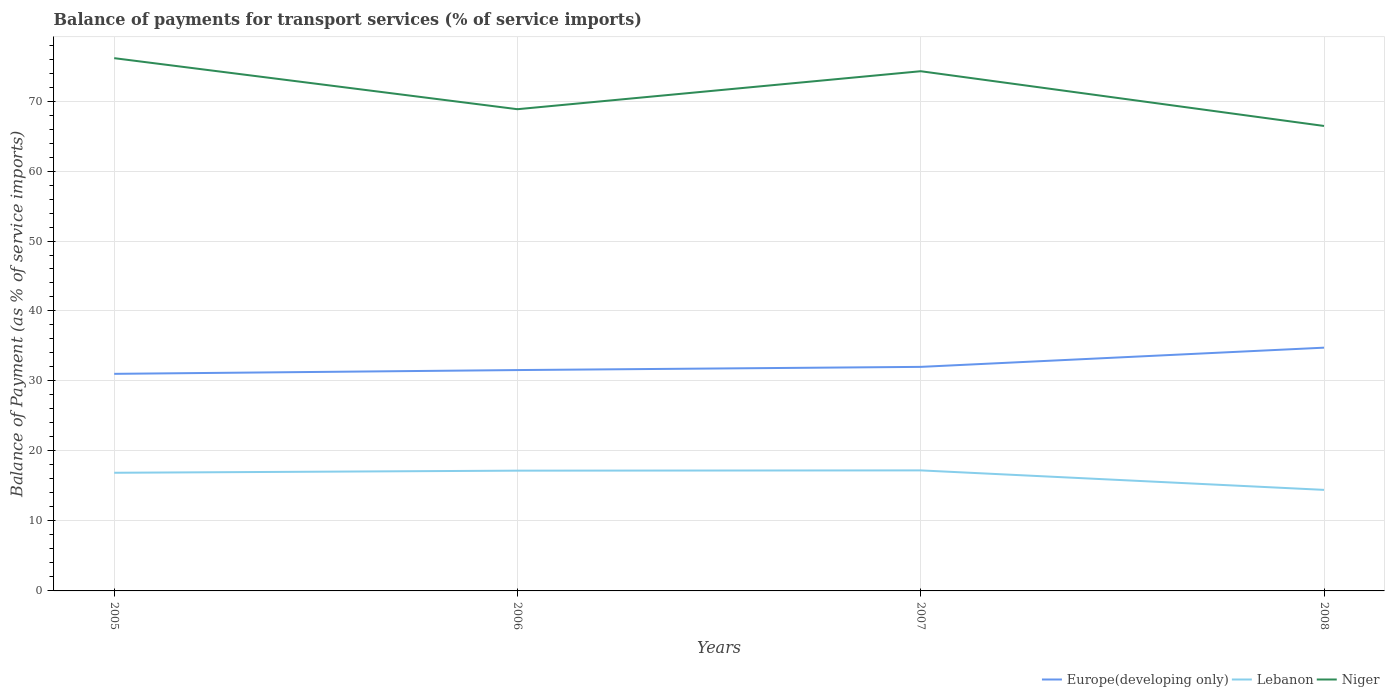How many different coloured lines are there?
Make the answer very short. 3. Does the line corresponding to Niger intersect with the line corresponding to Lebanon?
Provide a short and direct response. No. Across all years, what is the maximum balance of payments for transport services in Lebanon?
Provide a short and direct response. 14.44. In which year was the balance of payments for transport services in Lebanon maximum?
Offer a very short reply. 2008. What is the total balance of payments for transport services in Europe(developing only) in the graph?
Offer a very short reply. -3.2. What is the difference between the highest and the second highest balance of payments for transport services in Europe(developing only)?
Your response must be concise. 3.74. What is the difference between the highest and the lowest balance of payments for transport services in Lebanon?
Offer a very short reply. 3. Is the balance of payments for transport services in Lebanon strictly greater than the balance of payments for transport services in Niger over the years?
Offer a very short reply. Yes. How many years are there in the graph?
Offer a very short reply. 4. Does the graph contain any zero values?
Offer a terse response. No. Does the graph contain grids?
Make the answer very short. Yes. How are the legend labels stacked?
Offer a terse response. Horizontal. What is the title of the graph?
Your answer should be very brief. Balance of payments for transport services (% of service imports). Does "Central African Republic" appear as one of the legend labels in the graph?
Ensure brevity in your answer.  No. What is the label or title of the Y-axis?
Your response must be concise. Balance of Payment (as % of service imports). What is the Balance of Payment (as % of service imports) of Europe(developing only) in 2005?
Keep it short and to the point. 31.02. What is the Balance of Payment (as % of service imports) of Lebanon in 2005?
Provide a short and direct response. 16.88. What is the Balance of Payment (as % of service imports) in Niger in 2005?
Give a very brief answer. 76.13. What is the Balance of Payment (as % of service imports) in Europe(developing only) in 2006?
Your answer should be very brief. 31.56. What is the Balance of Payment (as % of service imports) in Lebanon in 2006?
Give a very brief answer. 17.19. What is the Balance of Payment (as % of service imports) in Niger in 2006?
Your answer should be very brief. 68.83. What is the Balance of Payment (as % of service imports) in Europe(developing only) in 2007?
Give a very brief answer. 32.01. What is the Balance of Payment (as % of service imports) of Lebanon in 2007?
Ensure brevity in your answer.  17.22. What is the Balance of Payment (as % of service imports) in Niger in 2007?
Ensure brevity in your answer.  74.26. What is the Balance of Payment (as % of service imports) in Europe(developing only) in 2008?
Keep it short and to the point. 34.76. What is the Balance of Payment (as % of service imports) in Lebanon in 2008?
Offer a very short reply. 14.44. What is the Balance of Payment (as % of service imports) in Niger in 2008?
Keep it short and to the point. 66.44. Across all years, what is the maximum Balance of Payment (as % of service imports) of Europe(developing only)?
Make the answer very short. 34.76. Across all years, what is the maximum Balance of Payment (as % of service imports) in Lebanon?
Provide a short and direct response. 17.22. Across all years, what is the maximum Balance of Payment (as % of service imports) in Niger?
Offer a terse response. 76.13. Across all years, what is the minimum Balance of Payment (as % of service imports) of Europe(developing only)?
Your answer should be very brief. 31.02. Across all years, what is the minimum Balance of Payment (as % of service imports) of Lebanon?
Provide a succinct answer. 14.44. Across all years, what is the minimum Balance of Payment (as % of service imports) of Niger?
Your answer should be compact. 66.44. What is the total Balance of Payment (as % of service imports) in Europe(developing only) in the graph?
Offer a terse response. 129.35. What is the total Balance of Payment (as % of service imports) of Lebanon in the graph?
Your answer should be very brief. 65.73. What is the total Balance of Payment (as % of service imports) in Niger in the graph?
Ensure brevity in your answer.  285.66. What is the difference between the Balance of Payment (as % of service imports) of Europe(developing only) in 2005 and that in 2006?
Give a very brief answer. -0.54. What is the difference between the Balance of Payment (as % of service imports) in Lebanon in 2005 and that in 2006?
Ensure brevity in your answer.  -0.3. What is the difference between the Balance of Payment (as % of service imports) of Niger in 2005 and that in 2006?
Your response must be concise. 7.29. What is the difference between the Balance of Payment (as % of service imports) in Europe(developing only) in 2005 and that in 2007?
Keep it short and to the point. -1. What is the difference between the Balance of Payment (as % of service imports) in Lebanon in 2005 and that in 2007?
Offer a very short reply. -0.34. What is the difference between the Balance of Payment (as % of service imports) of Niger in 2005 and that in 2007?
Make the answer very short. 1.87. What is the difference between the Balance of Payment (as % of service imports) in Europe(developing only) in 2005 and that in 2008?
Keep it short and to the point. -3.74. What is the difference between the Balance of Payment (as % of service imports) of Lebanon in 2005 and that in 2008?
Provide a short and direct response. 2.44. What is the difference between the Balance of Payment (as % of service imports) of Niger in 2005 and that in 2008?
Make the answer very short. 9.69. What is the difference between the Balance of Payment (as % of service imports) in Europe(developing only) in 2006 and that in 2007?
Ensure brevity in your answer.  -0.45. What is the difference between the Balance of Payment (as % of service imports) of Lebanon in 2006 and that in 2007?
Your answer should be very brief. -0.04. What is the difference between the Balance of Payment (as % of service imports) of Niger in 2006 and that in 2007?
Your answer should be compact. -5.43. What is the difference between the Balance of Payment (as % of service imports) of Europe(developing only) in 2006 and that in 2008?
Offer a very short reply. -3.2. What is the difference between the Balance of Payment (as % of service imports) in Lebanon in 2006 and that in 2008?
Your answer should be very brief. 2.75. What is the difference between the Balance of Payment (as % of service imports) of Niger in 2006 and that in 2008?
Give a very brief answer. 2.39. What is the difference between the Balance of Payment (as % of service imports) in Europe(developing only) in 2007 and that in 2008?
Give a very brief answer. -2.75. What is the difference between the Balance of Payment (as % of service imports) of Lebanon in 2007 and that in 2008?
Make the answer very short. 2.78. What is the difference between the Balance of Payment (as % of service imports) of Niger in 2007 and that in 2008?
Your answer should be very brief. 7.82. What is the difference between the Balance of Payment (as % of service imports) of Europe(developing only) in 2005 and the Balance of Payment (as % of service imports) of Lebanon in 2006?
Keep it short and to the point. 13.83. What is the difference between the Balance of Payment (as % of service imports) in Europe(developing only) in 2005 and the Balance of Payment (as % of service imports) in Niger in 2006?
Keep it short and to the point. -37.81. What is the difference between the Balance of Payment (as % of service imports) in Lebanon in 2005 and the Balance of Payment (as % of service imports) in Niger in 2006?
Provide a short and direct response. -51.95. What is the difference between the Balance of Payment (as % of service imports) in Europe(developing only) in 2005 and the Balance of Payment (as % of service imports) in Lebanon in 2007?
Give a very brief answer. 13.8. What is the difference between the Balance of Payment (as % of service imports) of Europe(developing only) in 2005 and the Balance of Payment (as % of service imports) of Niger in 2007?
Ensure brevity in your answer.  -43.24. What is the difference between the Balance of Payment (as % of service imports) of Lebanon in 2005 and the Balance of Payment (as % of service imports) of Niger in 2007?
Give a very brief answer. -57.38. What is the difference between the Balance of Payment (as % of service imports) of Europe(developing only) in 2005 and the Balance of Payment (as % of service imports) of Lebanon in 2008?
Your answer should be compact. 16.58. What is the difference between the Balance of Payment (as % of service imports) in Europe(developing only) in 2005 and the Balance of Payment (as % of service imports) in Niger in 2008?
Your answer should be very brief. -35.42. What is the difference between the Balance of Payment (as % of service imports) in Lebanon in 2005 and the Balance of Payment (as % of service imports) in Niger in 2008?
Offer a terse response. -49.56. What is the difference between the Balance of Payment (as % of service imports) in Europe(developing only) in 2006 and the Balance of Payment (as % of service imports) in Lebanon in 2007?
Give a very brief answer. 14.34. What is the difference between the Balance of Payment (as % of service imports) of Europe(developing only) in 2006 and the Balance of Payment (as % of service imports) of Niger in 2007?
Offer a terse response. -42.7. What is the difference between the Balance of Payment (as % of service imports) in Lebanon in 2006 and the Balance of Payment (as % of service imports) in Niger in 2007?
Your answer should be very brief. -57.08. What is the difference between the Balance of Payment (as % of service imports) of Europe(developing only) in 2006 and the Balance of Payment (as % of service imports) of Lebanon in 2008?
Offer a terse response. 17.12. What is the difference between the Balance of Payment (as % of service imports) in Europe(developing only) in 2006 and the Balance of Payment (as % of service imports) in Niger in 2008?
Your answer should be compact. -34.88. What is the difference between the Balance of Payment (as % of service imports) in Lebanon in 2006 and the Balance of Payment (as % of service imports) in Niger in 2008?
Ensure brevity in your answer.  -49.25. What is the difference between the Balance of Payment (as % of service imports) in Europe(developing only) in 2007 and the Balance of Payment (as % of service imports) in Lebanon in 2008?
Your answer should be very brief. 17.57. What is the difference between the Balance of Payment (as % of service imports) in Europe(developing only) in 2007 and the Balance of Payment (as % of service imports) in Niger in 2008?
Provide a short and direct response. -34.43. What is the difference between the Balance of Payment (as % of service imports) in Lebanon in 2007 and the Balance of Payment (as % of service imports) in Niger in 2008?
Keep it short and to the point. -49.22. What is the average Balance of Payment (as % of service imports) in Europe(developing only) per year?
Give a very brief answer. 32.34. What is the average Balance of Payment (as % of service imports) in Lebanon per year?
Provide a succinct answer. 16.43. What is the average Balance of Payment (as % of service imports) of Niger per year?
Your response must be concise. 71.42. In the year 2005, what is the difference between the Balance of Payment (as % of service imports) of Europe(developing only) and Balance of Payment (as % of service imports) of Lebanon?
Your response must be concise. 14.13. In the year 2005, what is the difference between the Balance of Payment (as % of service imports) in Europe(developing only) and Balance of Payment (as % of service imports) in Niger?
Your answer should be compact. -45.11. In the year 2005, what is the difference between the Balance of Payment (as % of service imports) of Lebanon and Balance of Payment (as % of service imports) of Niger?
Ensure brevity in your answer.  -59.24. In the year 2006, what is the difference between the Balance of Payment (as % of service imports) in Europe(developing only) and Balance of Payment (as % of service imports) in Lebanon?
Make the answer very short. 14.37. In the year 2006, what is the difference between the Balance of Payment (as % of service imports) in Europe(developing only) and Balance of Payment (as % of service imports) in Niger?
Provide a succinct answer. -37.27. In the year 2006, what is the difference between the Balance of Payment (as % of service imports) in Lebanon and Balance of Payment (as % of service imports) in Niger?
Make the answer very short. -51.65. In the year 2007, what is the difference between the Balance of Payment (as % of service imports) in Europe(developing only) and Balance of Payment (as % of service imports) in Lebanon?
Make the answer very short. 14.79. In the year 2007, what is the difference between the Balance of Payment (as % of service imports) in Europe(developing only) and Balance of Payment (as % of service imports) in Niger?
Provide a succinct answer. -42.25. In the year 2007, what is the difference between the Balance of Payment (as % of service imports) of Lebanon and Balance of Payment (as % of service imports) of Niger?
Make the answer very short. -57.04. In the year 2008, what is the difference between the Balance of Payment (as % of service imports) of Europe(developing only) and Balance of Payment (as % of service imports) of Lebanon?
Provide a succinct answer. 20.32. In the year 2008, what is the difference between the Balance of Payment (as % of service imports) of Europe(developing only) and Balance of Payment (as % of service imports) of Niger?
Provide a short and direct response. -31.68. In the year 2008, what is the difference between the Balance of Payment (as % of service imports) of Lebanon and Balance of Payment (as % of service imports) of Niger?
Make the answer very short. -52. What is the ratio of the Balance of Payment (as % of service imports) of Europe(developing only) in 2005 to that in 2006?
Offer a terse response. 0.98. What is the ratio of the Balance of Payment (as % of service imports) in Lebanon in 2005 to that in 2006?
Provide a succinct answer. 0.98. What is the ratio of the Balance of Payment (as % of service imports) of Niger in 2005 to that in 2006?
Provide a succinct answer. 1.11. What is the ratio of the Balance of Payment (as % of service imports) of Europe(developing only) in 2005 to that in 2007?
Give a very brief answer. 0.97. What is the ratio of the Balance of Payment (as % of service imports) of Lebanon in 2005 to that in 2007?
Keep it short and to the point. 0.98. What is the ratio of the Balance of Payment (as % of service imports) in Niger in 2005 to that in 2007?
Ensure brevity in your answer.  1.03. What is the ratio of the Balance of Payment (as % of service imports) of Europe(developing only) in 2005 to that in 2008?
Provide a short and direct response. 0.89. What is the ratio of the Balance of Payment (as % of service imports) of Lebanon in 2005 to that in 2008?
Offer a very short reply. 1.17. What is the ratio of the Balance of Payment (as % of service imports) of Niger in 2005 to that in 2008?
Offer a very short reply. 1.15. What is the ratio of the Balance of Payment (as % of service imports) of Europe(developing only) in 2006 to that in 2007?
Make the answer very short. 0.99. What is the ratio of the Balance of Payment (as % of service imports) in Niger in 2006 to that in 2007?
Offer a terse response. 0.93. What is the ratio of the Balance of Payment (as % of service imports) of Europe(developing only) in 2006 to that in 2008?
Your response must be concise. 0.91. What is the ratio of the Balance of Payment (as % of service imports) of Lebanon in 2006 to that in 2008?
Your response must be concise. 1.19. What is the ratio of the Balance of Payment (as % of service imports) in Niger in 2006 to that in 2008?
Provide a succinct answer. 1.04. What is the ratio of the Balance of Payment (as % of service imports) in Europe(developing only) in 2007 to that in 2008?
Keep it short and to the point. 0.92. What is the ratio of the Balance of Payment (as % of service imports) of Lebanon in 2007 to that in 2008?
Your answer should be compact. 1.19. What is the ratio of the Balance of Payment (as % of service imports) of Niger in 2007 to that in 2008?
Offer a very short reply. 1.12. What is the difference between the highest and the second highest Balance of Payment (as % of service imports) in Europe(developing only)?
Keep it short and to the point. 2.75. What is the difference between the highest and the second highest Balance of Payment (as % of service imports) in Lebanon?
Make the answer very short. 0.04. What is the difference between the highest and the second highest Balance of Payment (as % of service imports) of Niger?
Your answer should be very brief. 1.87. What is the difference between the highest and the lowest Balance of Payment (as % of service imports) of Europe(developing only)?
Give a very brief answer. 3.74. What is the difference between the highest and the lowest Balance of Payment (as % of service imports) of Lebanon?
Provide a succinct answer. 2.78. What is the difference between the highest and the lowest Balance of Payment (as % of service imports) in Niger?
Ensure brevity in your answer.  9.69. 